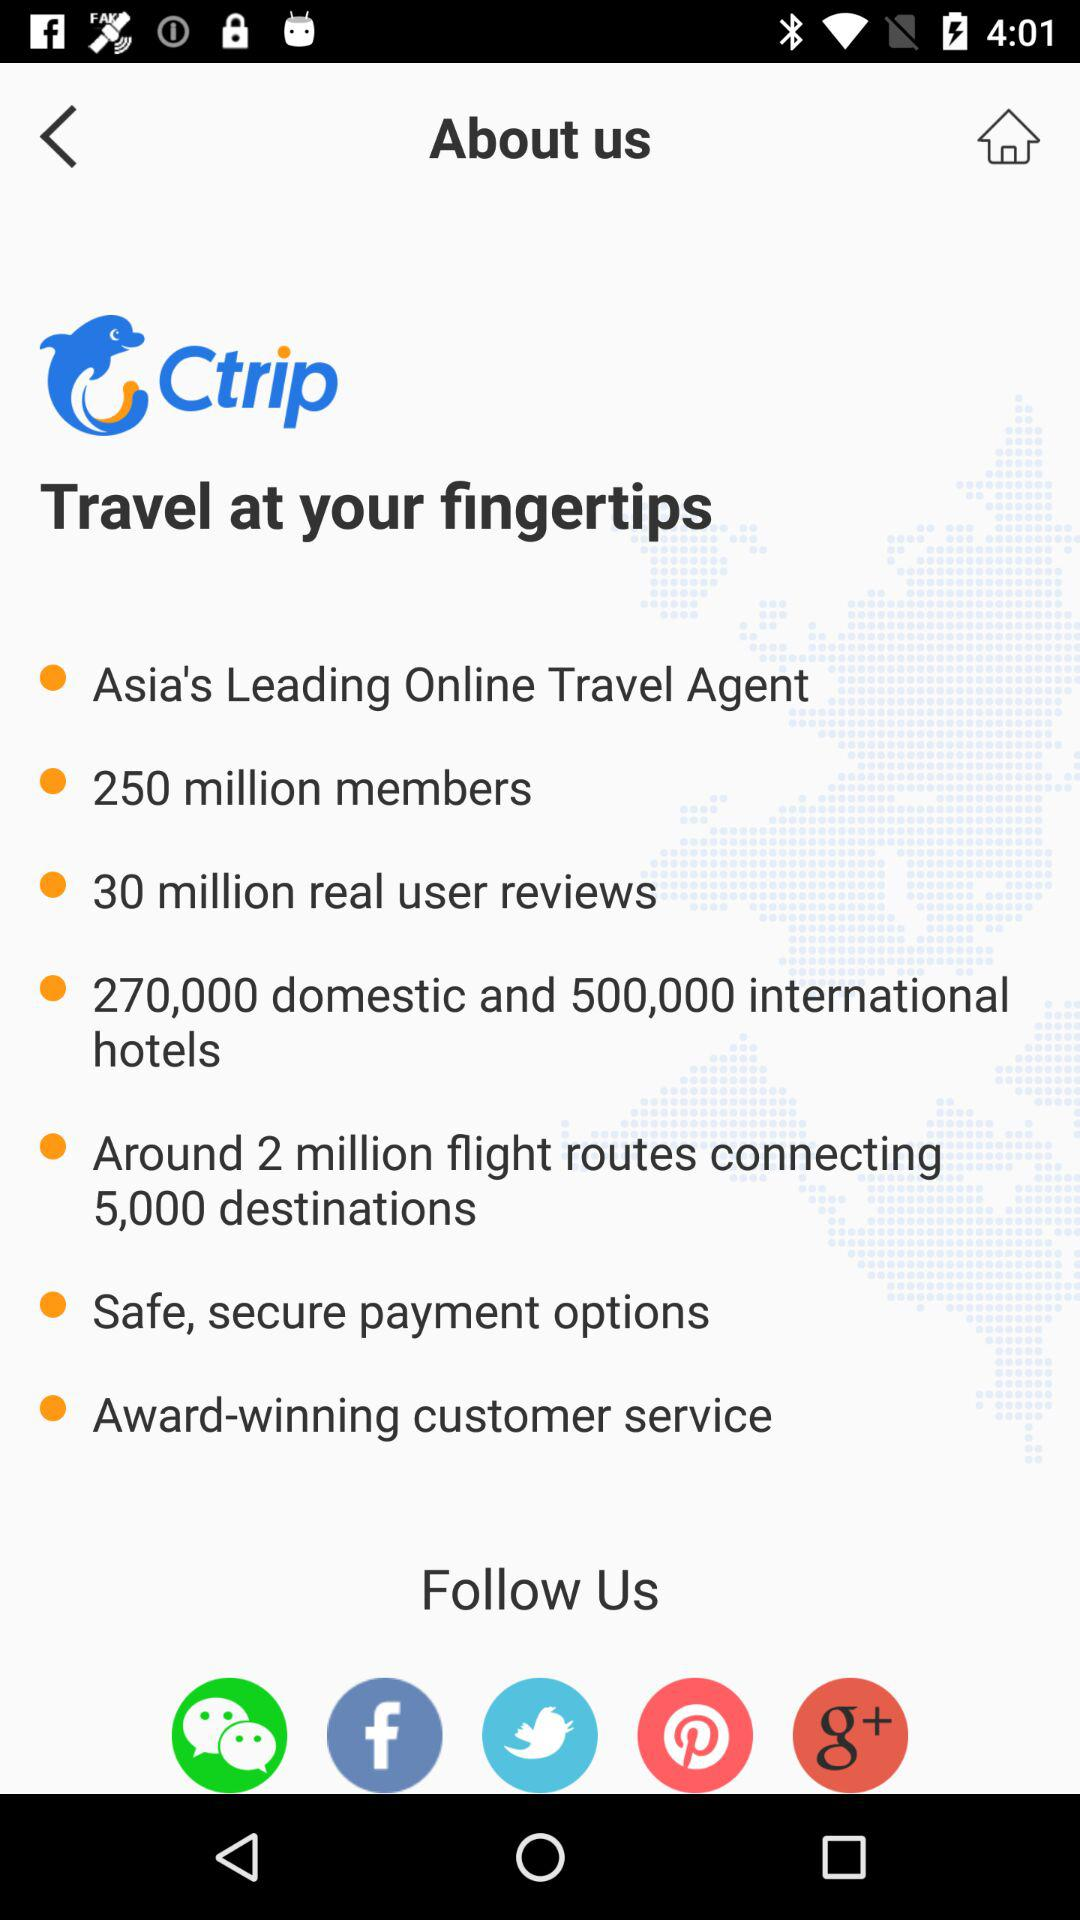How many flight routes are there for 5000 destinations? There are around 2 million flight routes to 5000 destinations. 